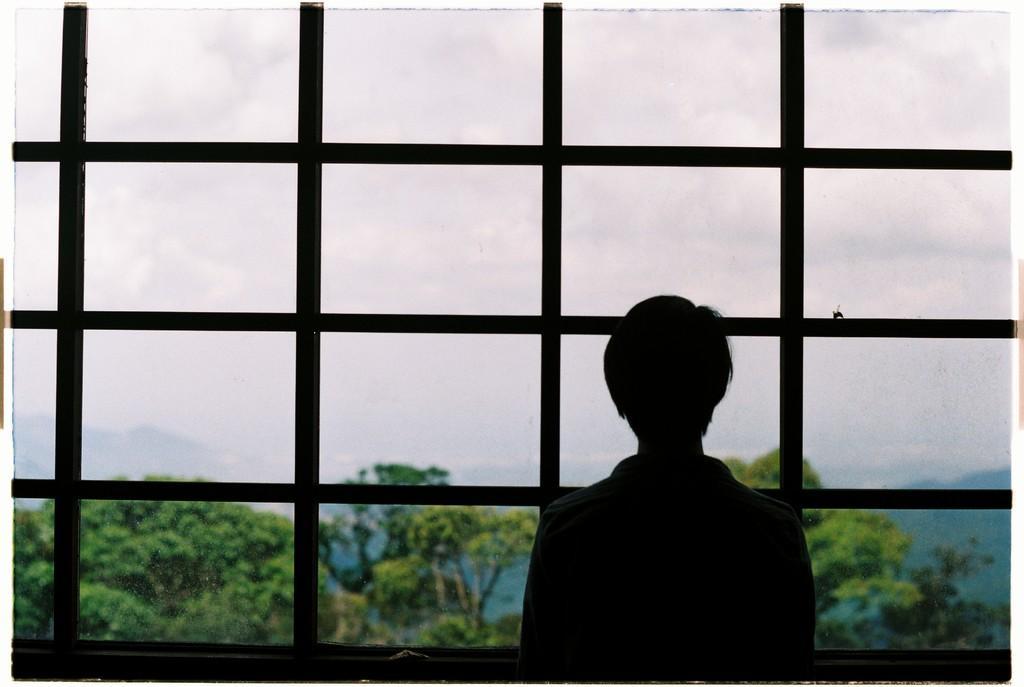How would you summarize this image in a sentence or two? In this image there is a person standing and watching outside through the window, on the other side of the window there are trees and mountains. 